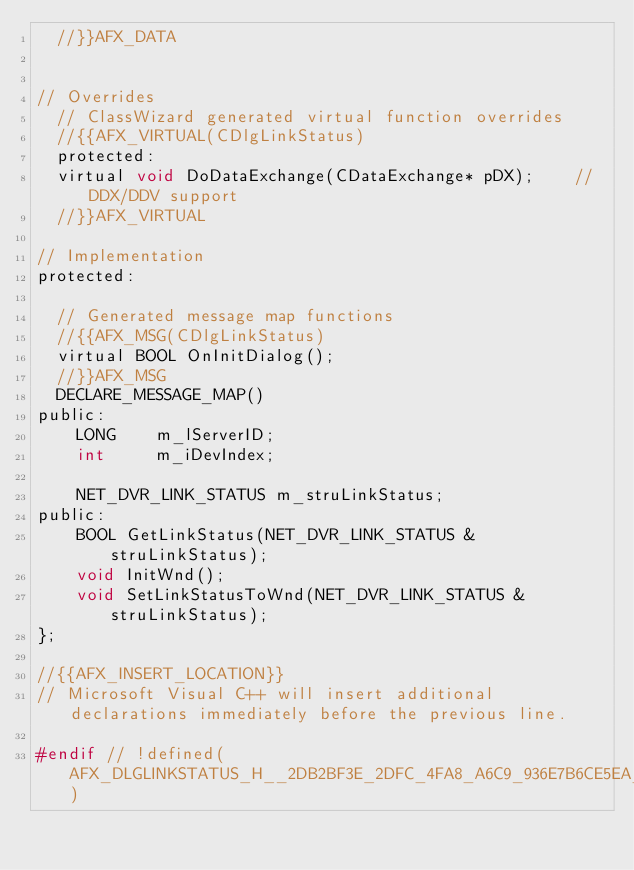<code> <loc_0><loc_0><loc_500><loc_500><_C_>	//}}AFX_DATA


// Overrides
	// ClassWizard generated virtual function overrides
	//{{AFX_VIRTUAL(CDlgLinkStatus)
	protected:
	virtual void DoDataExchange(CDataExchange* pDX);    // DDX/DDV support
	//}}AFX_VIRTUAL

// Implementation
protected:

	// Generated message map functions
	//{{AFX_MSG(CDlgLinkStatus)
	virtual BOOL OnInitDialog();
	//}}AFX_MSG
	DECLARE_MESSAGE_MAP()
public:
    LONG    m_lServerID;
    int     m_iDevIndex;

    NET_DVR_LINK_STATUS m_struLinkStatus;
public:
    BOOL GetLinkStatus(NET_DVR_LINK_STATUS &struLinkStatus);
    void InitWnd();
    void SetLinkStatusToWnd(NET_DVR_LINK_STATUS &struLinkStatus);
};

//{{AFX_INSERT_LOCATION}}
// Microsoft Visual C++ will insert additional declarations immediately before the previous line.

#endif // !defined(AFX_DLGLINKSTATUS_H__2DB2BF3E_2DFC_4FA8_A6C9_936E7B6CE5EA__INCLUDED_)
</code> 